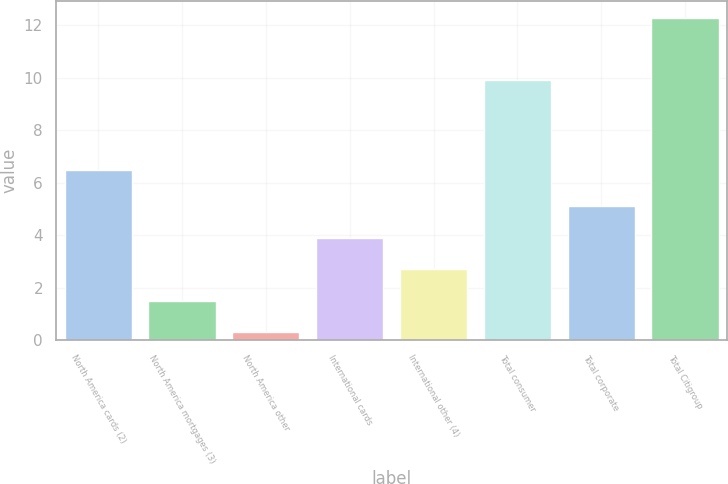Convert chart to OTSL. <chart><loc_0><loc_0><loc_500><loc_500><bar_chart><fcel>North America cards (2)<fcel>North America mortgages (3)<fcel>North America other<fcel>International cards<fcel>International other (4)<fcel>Total consumer<fcel>Total corporate<fcel>Total Citigroup<nl><fcel>6.5<fcel>1.5<fcel>0.3<fcel>3.9<fcel>2.7<fcel>9.9<fcel>5.1<fcel>12.3<nl></chart> 